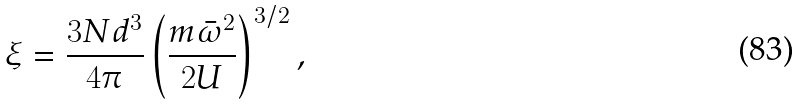Convert formula to latex. <formula><loc_0><loc_0><loc_500><loc_500>\xi = \frac { 3 N d ^ { 3 } } { 4 \pi } \left ( \frac { m \bar { \omega } ^ { 2 } } { 2 U } \right ) ^ { 3 / 2 } ,</formula> 